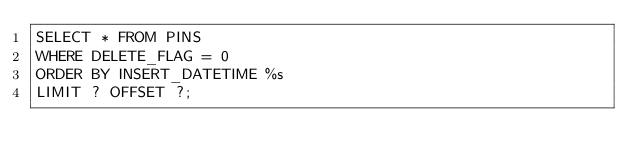Convert code to text. <code><loc_0><loc_0><loc_500><loc_500><_SQL_>SELECT * FROM PINS
WHERE DELETE_FLAG = 0
ORDER BY INSERT_DATETIME %s
LIMIT ? OFFSET ?;
</code> 